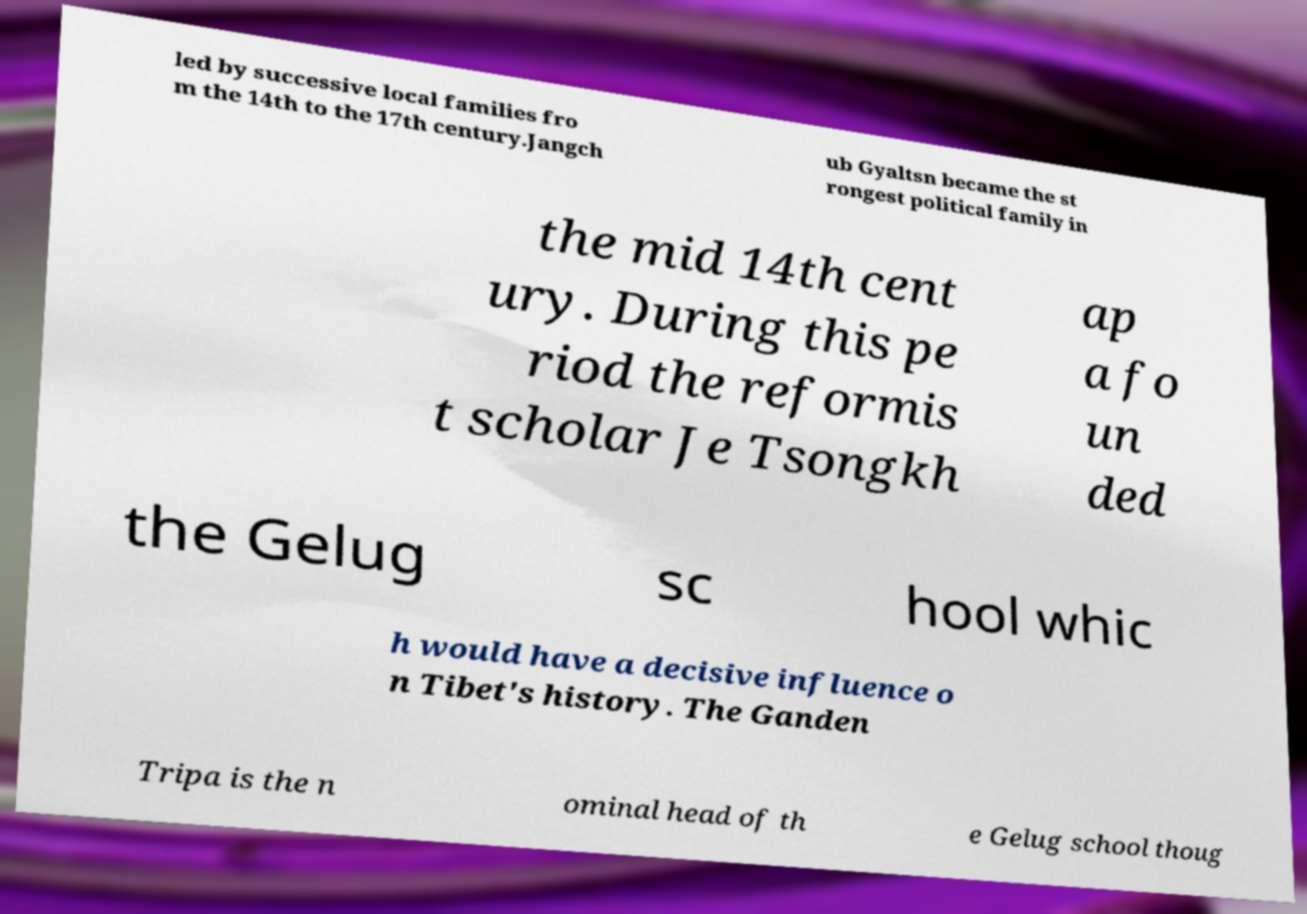Could you extract and type out the text from this image? led by successive local families fro m the 14th to the 17th century.Jangch ub Gyaltsn became the st rongest political family in the mid 14th cent ury. During this pe riod the reformis t scholar Je Tsongkh ap a fo un ded the Gelug sc hool whic h would have a decisive influence o n Tibet's history. The Ganden Tripa is the n ominal head of th e Gelug school thoug 